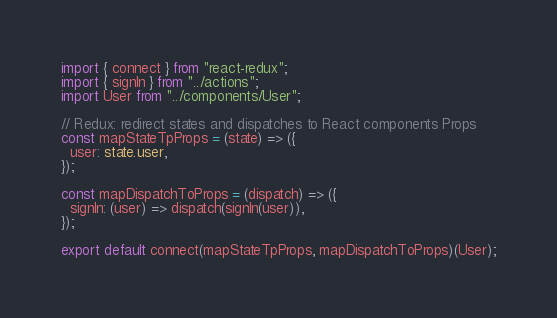<code> <loc_0><loc_0><loc_500><loc_500><_TypeScript_>import { connect } from "react-redux";
import { signIn } from "../actions";
import User from "../components/User";

// Redux: redirect states and dispatches to React components Props
const mapStateTpProps = (state) => ({
  user: state.user,
});

const mapDispatchToProps = (dispatch) => ({
  signIn: (user) => dispatch(signIn(user)),
});

export default connect(mapStateTpProps, mapDispatchToProps)(User);
</code> 